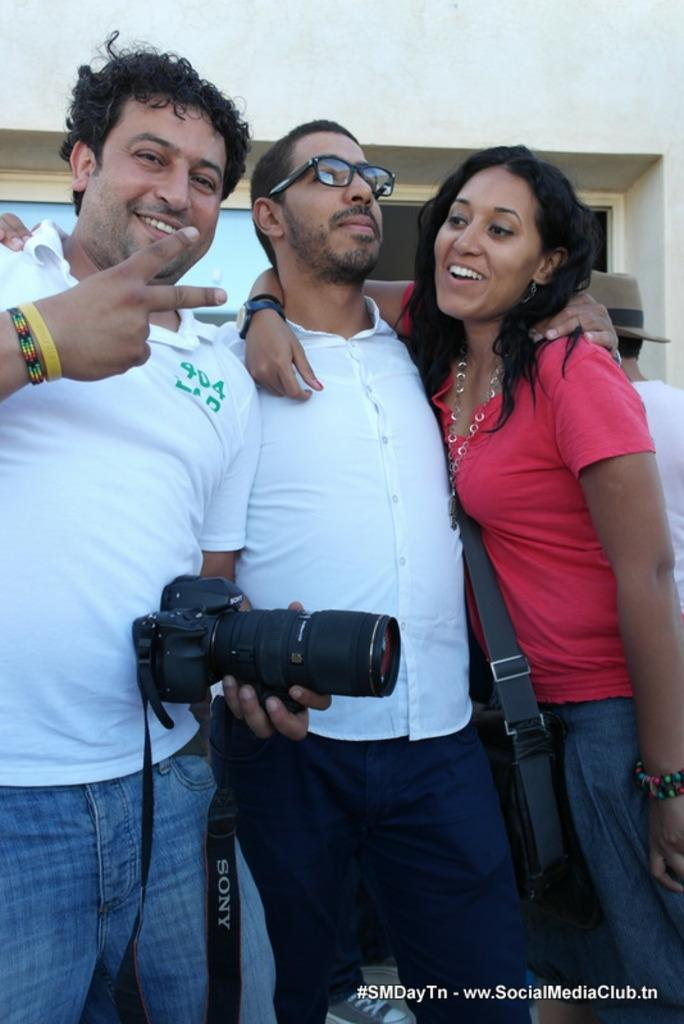How many pieces of paper are visible in the image? There are three pieces of paper in the image. How many people are present in the image? There are two men and one woman in the image. Where is the woman located in the image? The woman is on the right side of the image. What is one of the men holding in the image? One of the men is holding a camera. What type of shoes is the carpenter wearing in the image? There is no carpenter present in the image, and therefore no shoes to describe. How many passengers are visible in the image? There is no reference to passengers in the image, as it features people holding pieces of paper and a camera. 